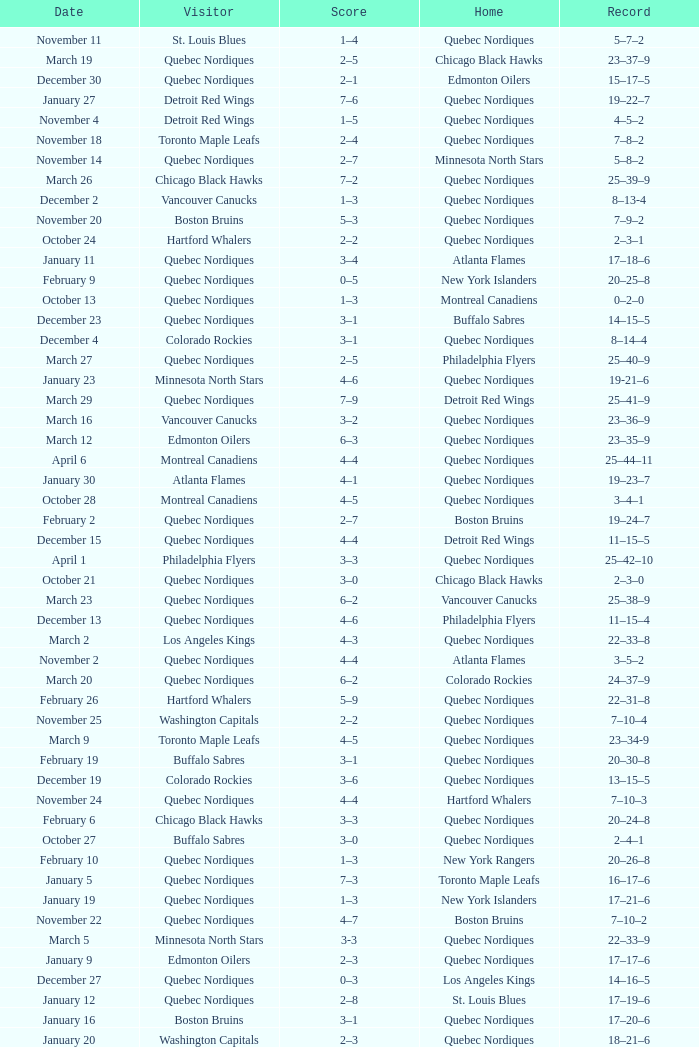Which Date has a Score of 2–7, and a Record of 5–8–2? November 14. 